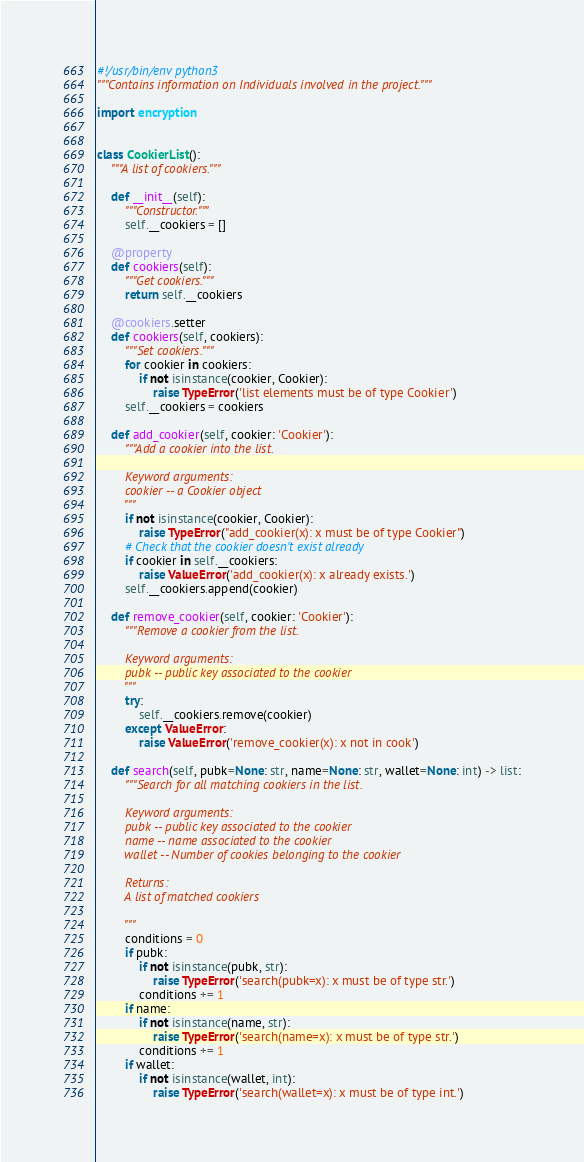Convert code to text. <code><loc_0><loc_0><loc_500><loc_500><_Python_>#!/usr/bin/env python3
"""Contains information on Individuals involved in the project."""

import encryption


class CookierList():
    """A list of cookiers."""

    def __init__(self):
        """Constructor."""
        self.__cookiers = []

    @property
    def cookiers(self):
        """Get cookiers."""
        return self.__cookiers

    @cookiers.setter
    def cookiers(self, cookiers):
        """Set cookiers."""
        for cookier in cookiers:
            if not isinstance(cookier, Cookier):
                raise TypeError('list elements must be of type Cookier')
        self.__cookiers = cookiers

    def add_cookier(self, cookier: 'Cookier'):
        """Add a cookier into the list.

        Keyword arguments:
        cookier -- a Cookier object
        """
        if not isinstance(cookier, Cookier):
            raise TypeError("add_cookier(x): x must be of type Cookier")
        # Check that the cookier doesn't exist already
        if cookier in self.__cookiers:
            raise ValueError('add_cookier(x): x already exists.')
        self.__cookiers.append(cookier)

    def remove_cookier(self, cookier: 'Cookier'):
        """Remove a cookier from the list.

        Keyword arguments:
        pubk -- public key associated to the cookier
        """
        try:
            self.__cookiers.remove(cookier)
        except ValueError:
            raise ValueError('remove_cookier(x): x not in cook')

    def search(self, pubk=None: str, name=None: str, wallet=None: int) -> list:
        """Search for all matching cookiers in the list.

        Keyword arguments:
        pubk -- public key associated to the cookier
        name -- name associated to the cookier
        wallet -- Number of cookies belonging to the cookier

        Returns:
        A list of matched cookiers

        """
        conditions = 0
        if pubk:
            if not isinstance(pubk, str):
                raise TypeError('search(pubk=x): x must be of type str.')
            conditions += 1
        if name:
            if not isinstance(name, str):
                raise TypeError('search(name=x): x must be of type str.')
            conditions += 1
        if wallet:
            if not isinstance(wallet, int):
                raise TypeError('search(wallet=x): x must be of type int.')</code> 